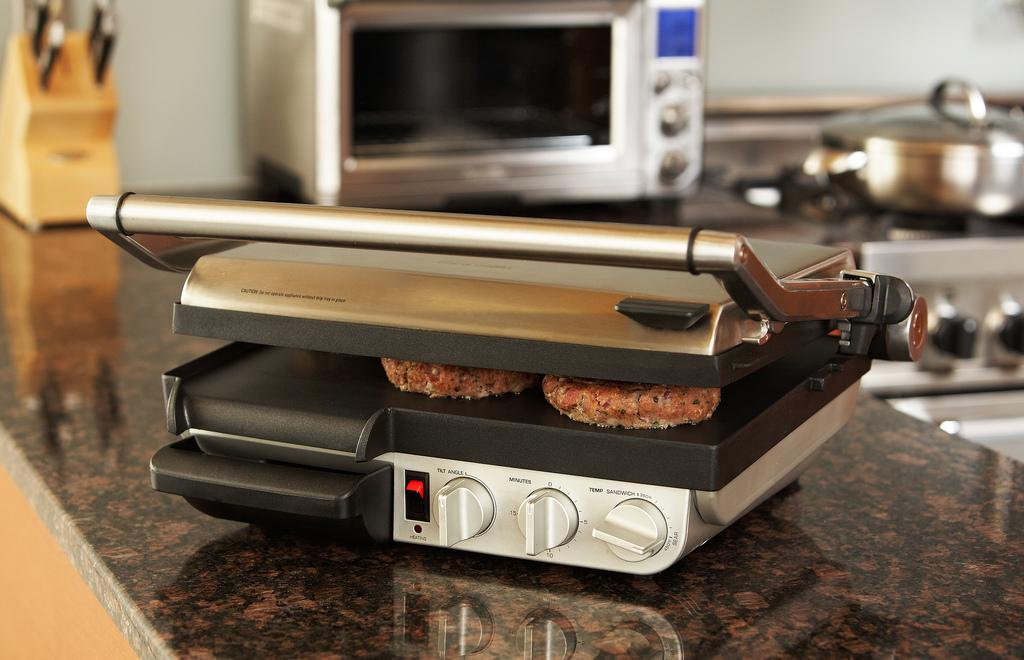<image>
Create a compact narrative representing the image presented. A silver pressed down grill with the timer set at 0. 